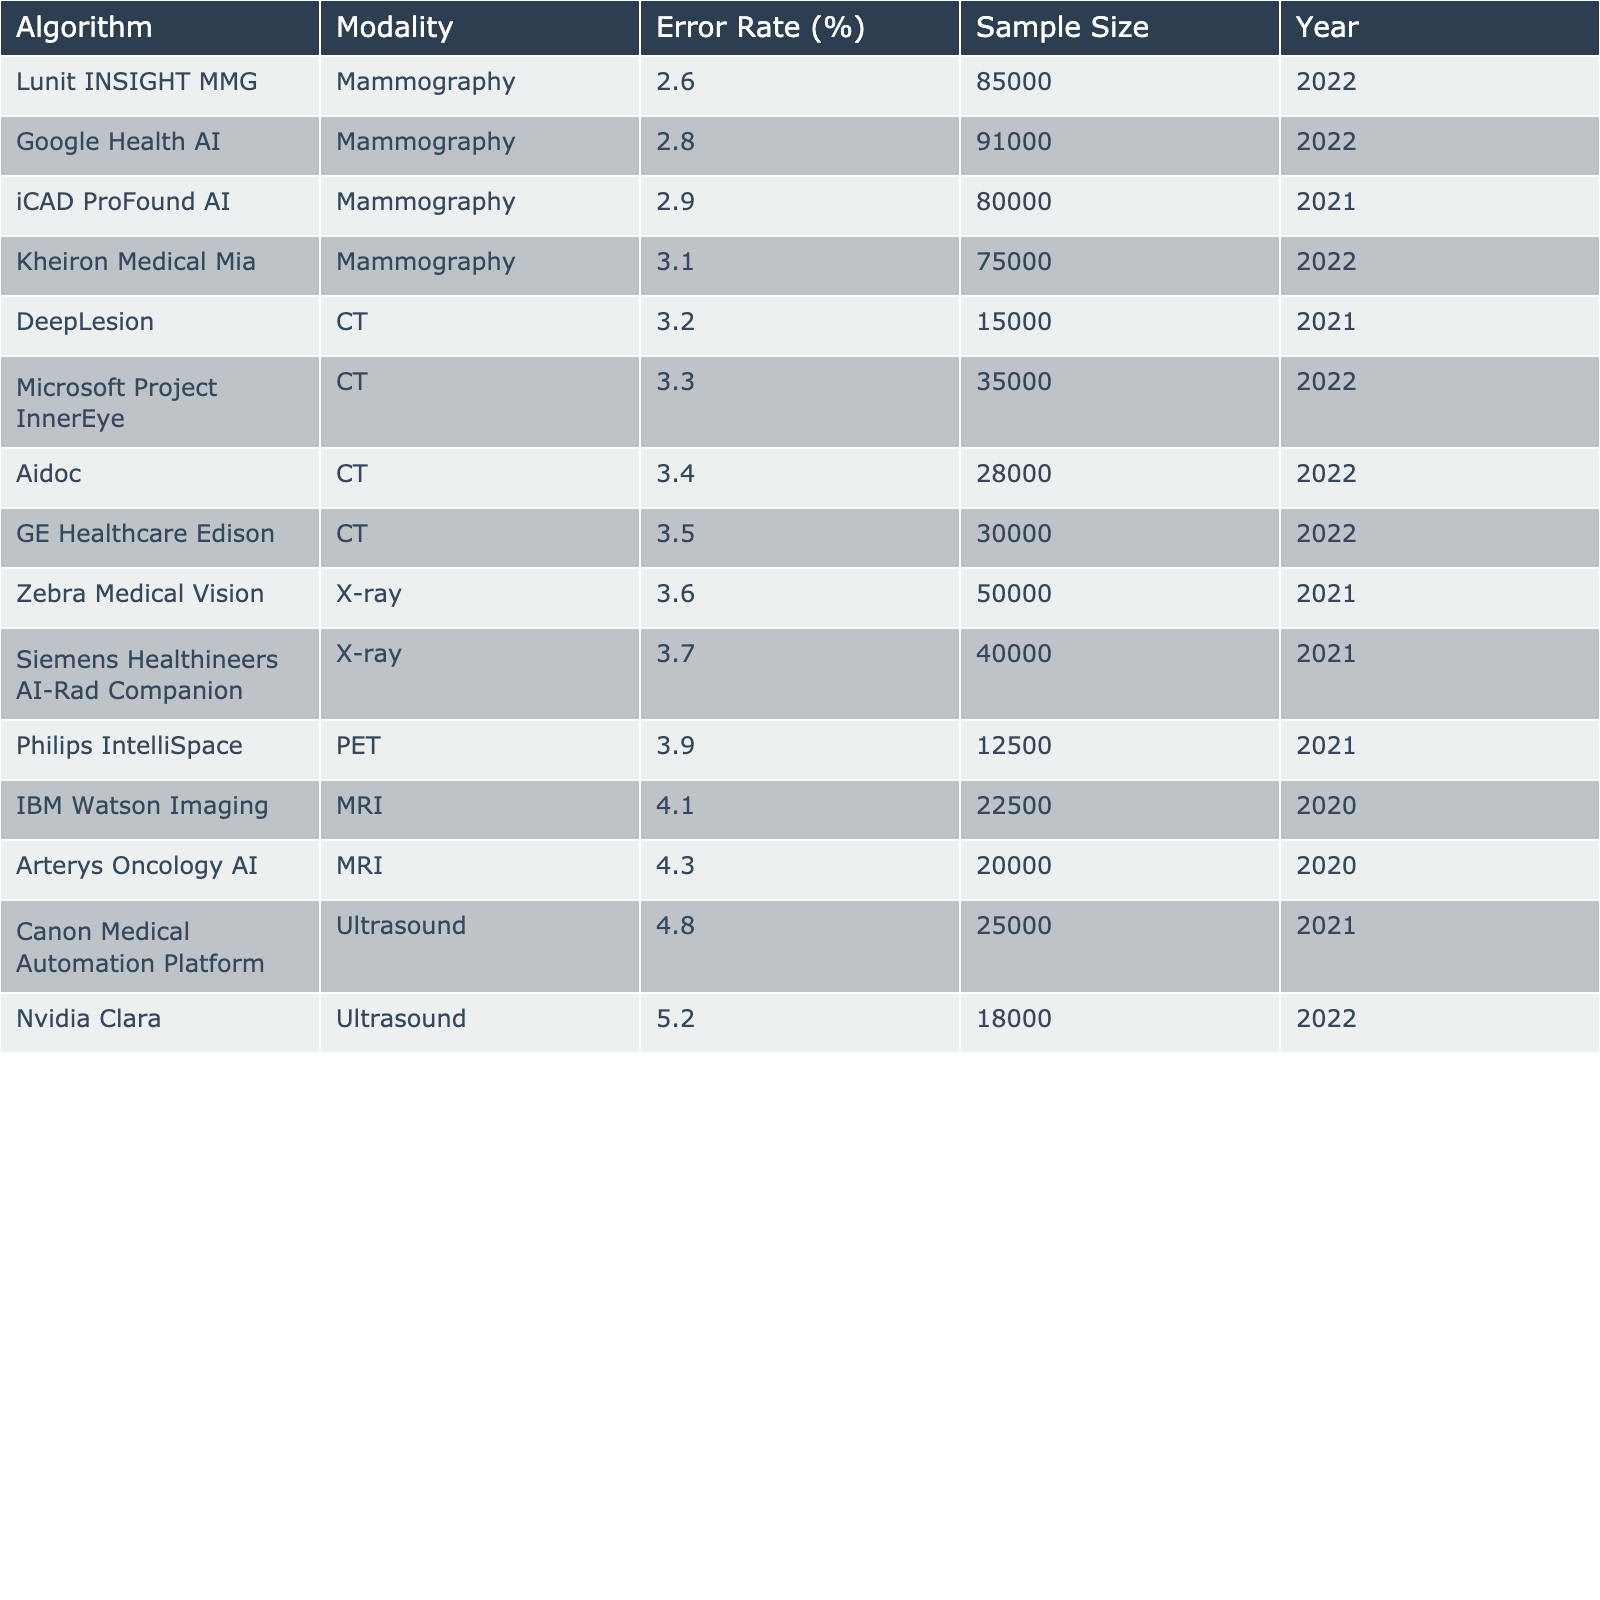What is the error rate of the Google Health AI algorithm? The table clearly shows that the Google Health AI algorithm has an error rate of 2.8%.
Answer: 2.8% How many algorithms have an error rate lower than 3%? By examining the table, two algorithms, Lunit INSIGHT MMG and Google Health AI, have error rates of 2.6% and 2.8%, respectively, which are both below 3%.
Answer: 2 Which imaging modality is associated with the highest error rate? From the table, we see that the Nvidia Clara algorithm for Ultrasound has the highest error rate of 5.2%.
Answer: Ultrasound What is the average error rate of Mammography algorithms in the table? There are four Mammography algorithms: Google Health AI (2.8%), Lunit INSIGHT MMG (2.6%), iCAD ProFound AI (2.9%), and Kheiron Medical Mia (3.1%). The sum is (2.8 + 2.6 + 2.9 + 3.1) = 11.4, and dividing by 4 gives an average of 11.4/4 = 2.85%.
Answer: 2.85% Is the error rate of the Siemens Healthineers AI-Rad Companion higher or lower than that of the Arterys Oncology AI? The Siemens Healthineers AI-Rad Companion has an error rate of 3.7%, while the Arterys Oncology AI has an error rate of 4.3%. Since 3.7% is lower than 4.3%, the former has a lower error rate.
Answer: Lower Which two algorithms have the closest error rates? By comparing the error rates, the algorithms with the closest values are Philips IntelliSpace (3.9%) and GE Healthcare Edison (3.5%). The difference between these two rates is minimal at 0.4%.
Answer: Philips IntelliSpace and GE Healthcare Edison What is the total sample size of the algorithms with error rates below 4%? The algorithms that have error rates below 4% are Lunit INSIGHT MMG (85000), Google Health AI (91000), iCAD ProFound AI (80000), and Kheiron Medical Mia (75000). The total sample size is (85000 + 91000 + 80000 + 75000) = 331000.
Answer: 331000 How many algorithms have a sample size greater than 30000? Looking at the table, there are five algorithms with a sample size greater than 30000: Google Health AI (91000), Siemens Healthineers AI-Rad Companion (40000), GE Healthcare Edison (30000), Aidoc (28000), and Canon Medical Automation Platform (25000). Only GE Healthcare Edison and Google Health AI exceed 30000. So the answer is 5.
Answer: 5 Which algorithm has the lowest error rate, and what is its sample size? The algorithm with the lowest error rate is Lunit INSIGHT MMG, which has an error rate of 2.6% and a sample size of 85000.
Answer: Lunit INSIGHT MMG, 85000 What percentage of algorithms use CT imaging modality? In the table, there are five algorithms that use CT: DeepLesion, GE Healthcare Edison, Microsoft Project InnerEye, Aidoc, and Siemens Healthineers AI-Rad Companion. Out of a total of 14 algorithms (from the table), (5/14) * 100 = 35.71%, rounding to 36%.
Answer: 36% 